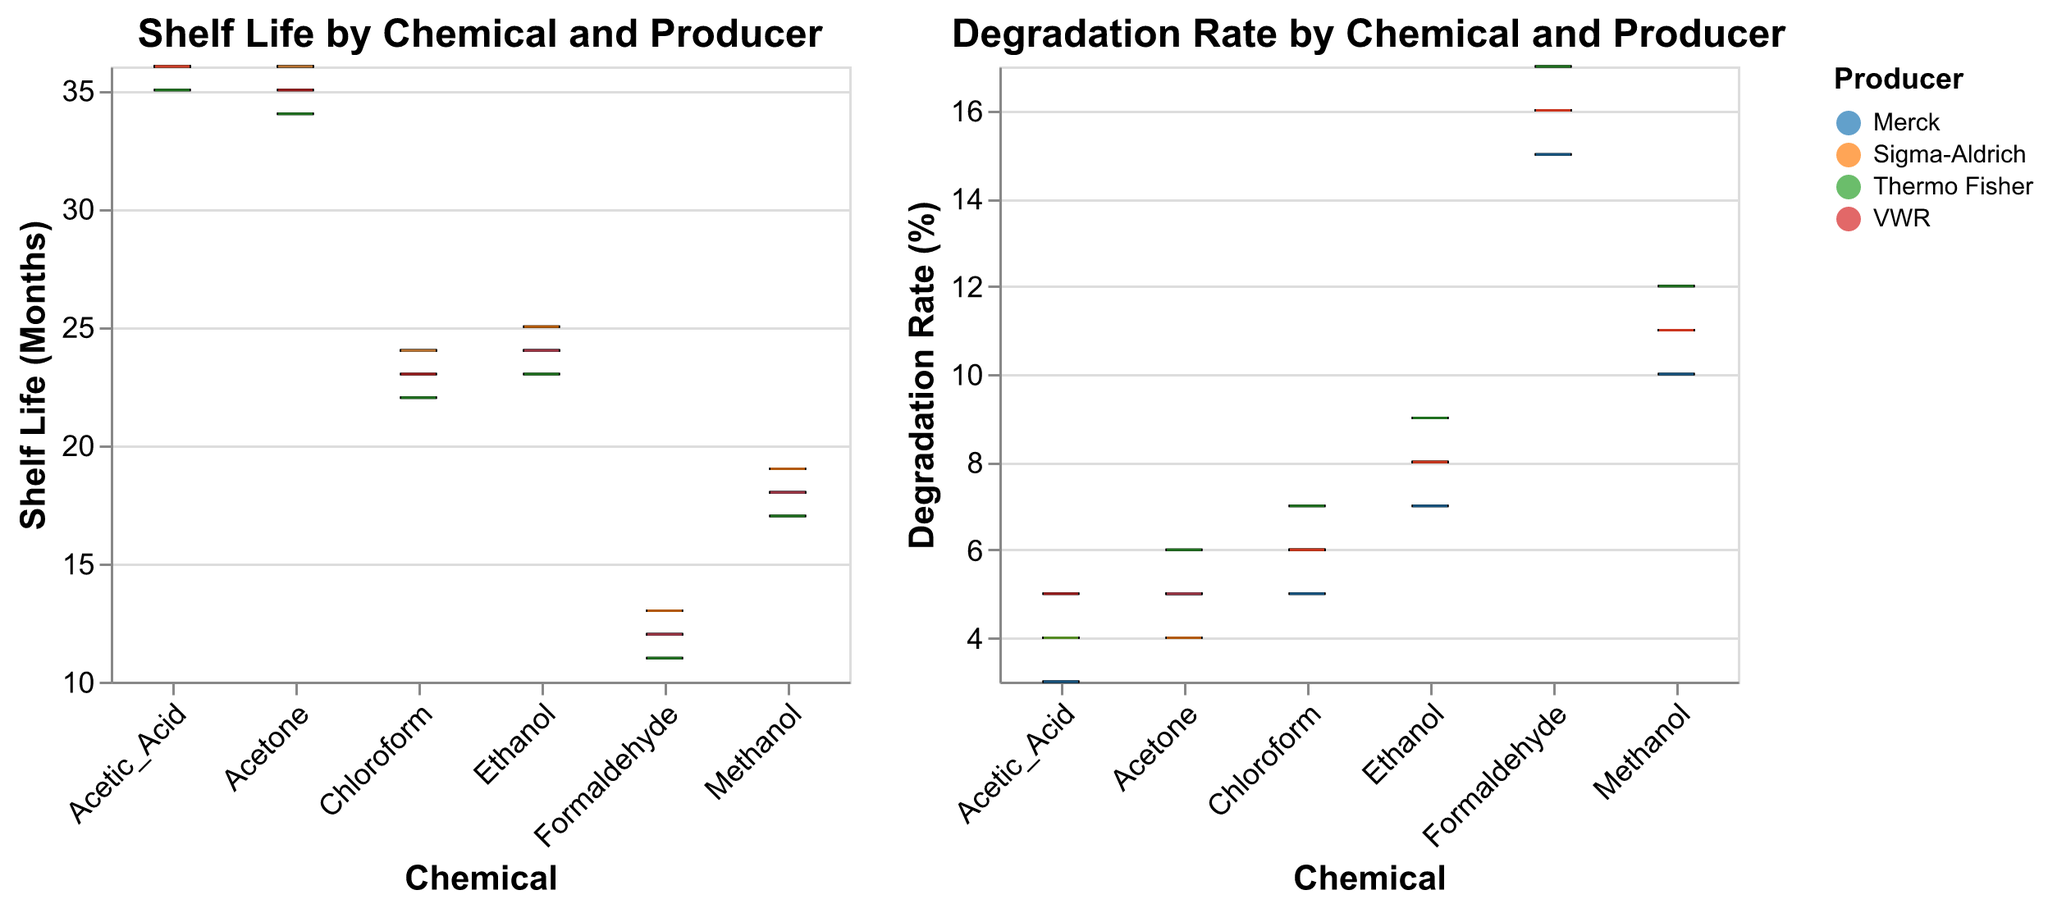What's the title of the first subplot? The title of the first subplot can be found at the top of the box plot on the left side. The title is "Shelf Life by Chemical and Producer".
Answer: Shelf Life by Chemical and Producer What is the producer with the highest shelf life for Acetone? Locate the Acetone box plot in the first subplot, differentiate between the four producers by their colored boxplots. The highest shelf life for Acetone is 36 months, associated with Merck and Sigma-Aldrich, identified by blue and orange colors respectively.
Answer: Merck, Sigma-Aldrich What's the range of the degradation rates for Ethanol across all producers? In the second subplot titled "Degradation Rate by Chemical and Producer", find the Ethanol box plot. Observe the min and max whiskers for Ethanol which indicate the degradation rates ranging from 7% to 9%.
Answer: 7% to 9% Which chemical from Thermo Fisher has the lowest shelf life? Check the first subplot "Shelf Life by Chemical and Producer", observe the Thermo Fisher represented in green. The lowest value for Thermo Fisher across all chemicals is Formaldehyde with 11 months.
Answer: Formaldehyde What is the median degradation rate for Formaldehyde across all producers? In the second subplot, find the Formaldehyde box plot and look at the middle line in the box representing the median value. For all Formaldehyde producers, the median degradation rate is 16%.
Answer: 16% Among Acetic Acid, which producer has the highest degradation rate? In the second subplot, find the Acetic Acid box plot section and compare the boxplots for each producer by their color. The highest degradation rate for Acetic Acid is 5%, associated with VWR marked in red.
Answer: VWR Determine the difference between the maximum shelf life for Acetic Acid and the minimum shelf life for Methanol. Locate the Acetic Acid and Methanol box plots in the first subplot. Identify the highest shelf life for Acetic Acid (36 months) and the lowest shelf life for Methanol (17 months). Subtract these values: 36 - 17 = 19.
Answer: 19 Which producer consistently shows higher degradation rates for all chemicals? Analyze the second subplot for all chemicals across various producers. Check if one producer stands out with consistently higher degradation rates. Thermo Fisher (green) consistently shows higher degradation rates for most chemicals.
Answer: Thermo Fisher How do the shelf life of Ethanol and Chloroform compare? Compare the box plots for Ethanol and Chloroform in the first subplot. Ethanol shelf life ranges roughly from 23 to 25 months, while Chloroform ranges from 22 to 24 months.
Answer: Ethanol generally has a slightly higher shelf life 